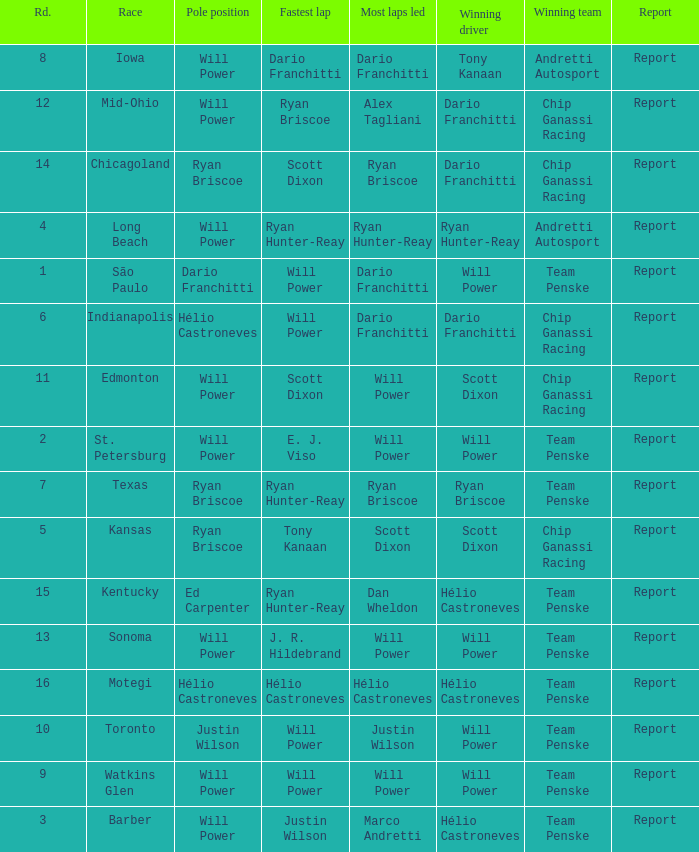In what position did the winning driver finish at Chicagoland? 1.0. 